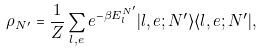<formula> <loc_0><loc_0><loc_500><loc_500>\rho _ { N ^ { \prime } } = \frac { 1 } { Z } \sum _ { l , e } e ^ { - \beta E ^ { N ^ { \prime } } _ { l } } | l , e ; N ^ { \prime } \rangle \langle l , e ; N ^ { \prime } | ,</formula> 